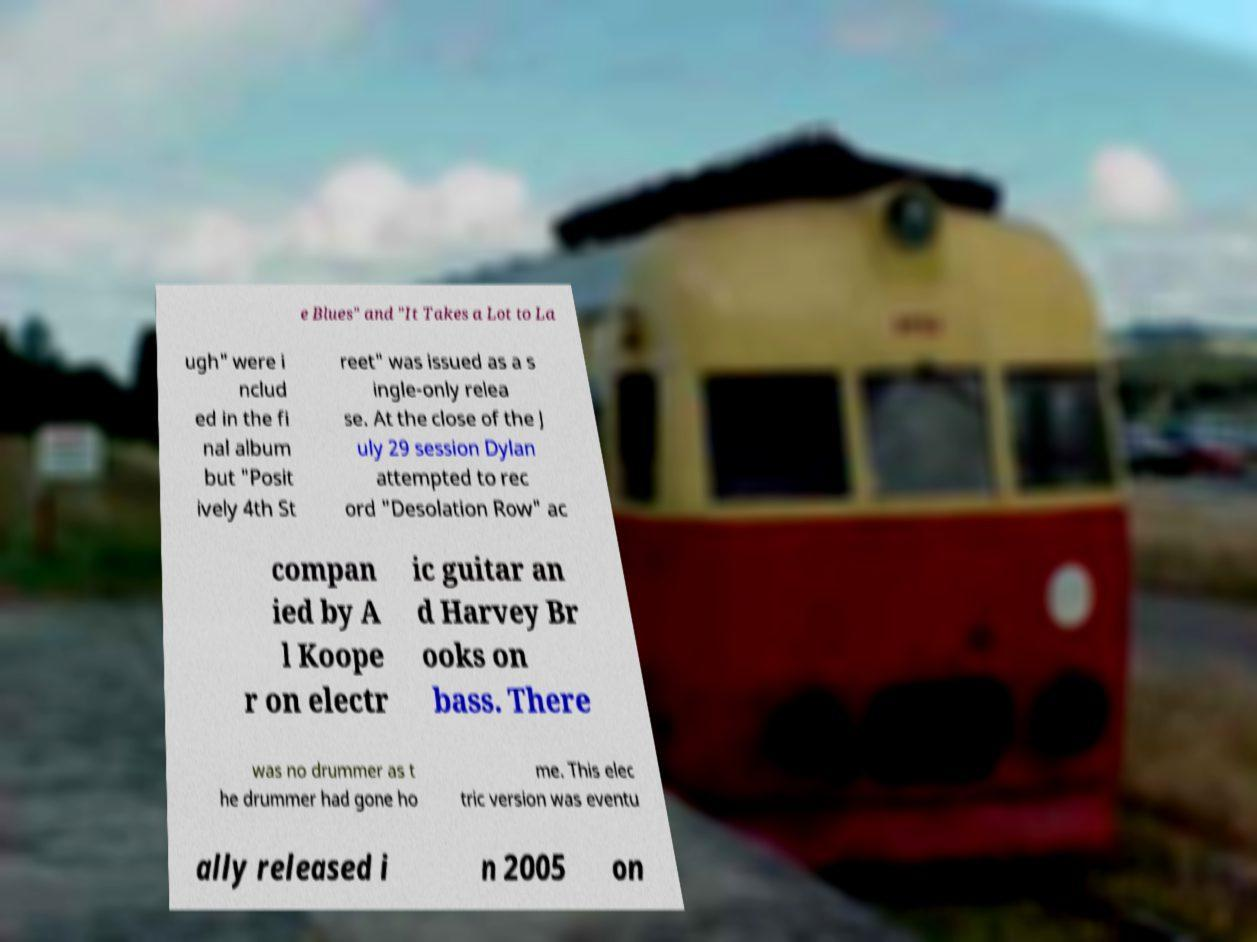Please read and relay the text visible in this image. What does it say? e Blues" and "It Takes a Lot to La ugh" were i nclud ed in the fi nal album but "Posit ively 4th St reet" was issued as a s ingle-only relea se. At the close of the J uly 29 session Dylan attempted to rec ord "Desolation Row" ac compan ied by A l Koope r on electr ic guitar an d Harvey Br ooks on bass. There was no drummer as t he drummer had gone ho me. This elec tric version was eventu ally released i n 2005 on 